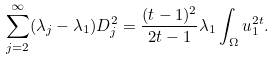Convert formula to latex. <formula><loc_0><loc_0><loc_500><loc_500>\sum _ { j = 2 } ^ { \infty } ( \lambda _ { j } - \lambda _ { 1 } ) D _ { j } ^ { 2 } = \frac { ( t - 1 ) ^ { 2 } } { 2 t - 1 } \lambda _ { 1 } \int _ { \Omega } u _ { 1 } ^ { 2 t } .</formula> 